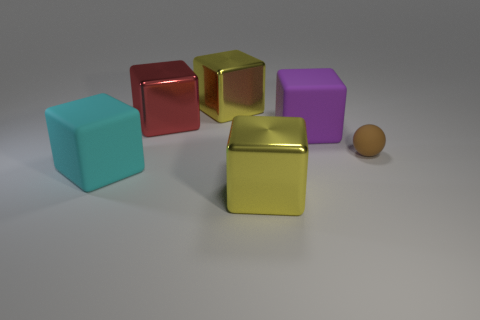There is a yellow block in front of the block right of the shiny object that is in front of the large cyan rubber cube; what is its size? The yellow block in question, when observed in relation to surrounding objects and assuming a consistent scale, appears to be of a large size, similar to the other surrounding blocks. 